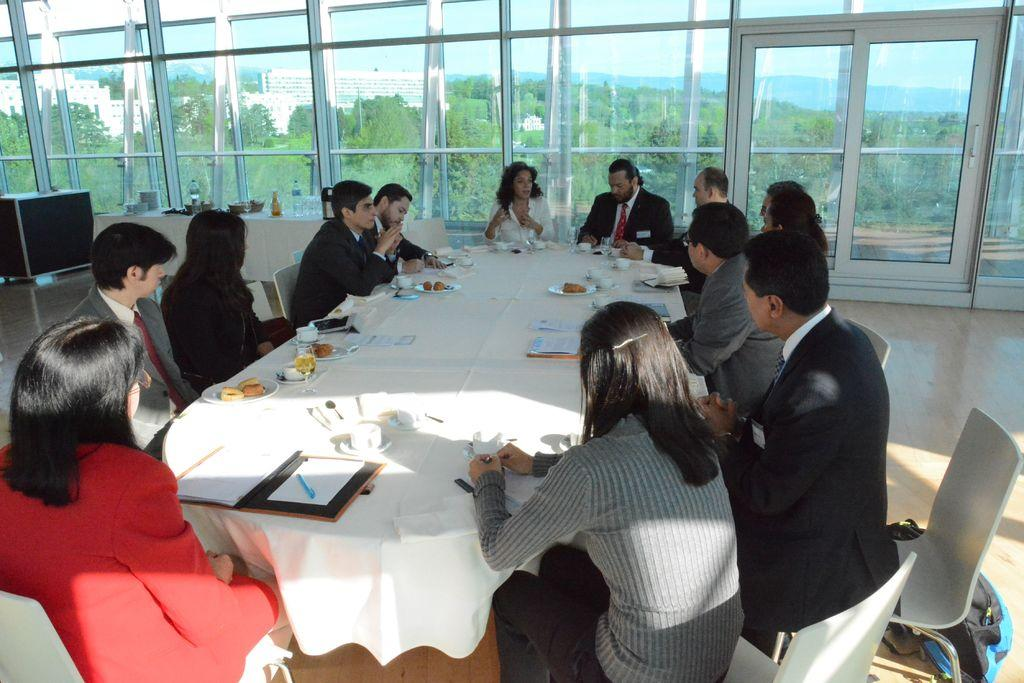How many people are in the image? There is a group of people in the image, but the exact number is not specified. What are the people doing in the image? The people are sitting on chairs and talking about something. How are the chairs arranged in the image? The chairs are arranged around a table. What can be seen outside the glass window in the image? Trees, buildings, and the sky are visible outside the window. What educational institution can be seen in the image? There is no educational institution present in the image. How are the people measuring the distance between the chairs in the image? The people are not measuring the distance between the chairs in the image; they are talking about something. 